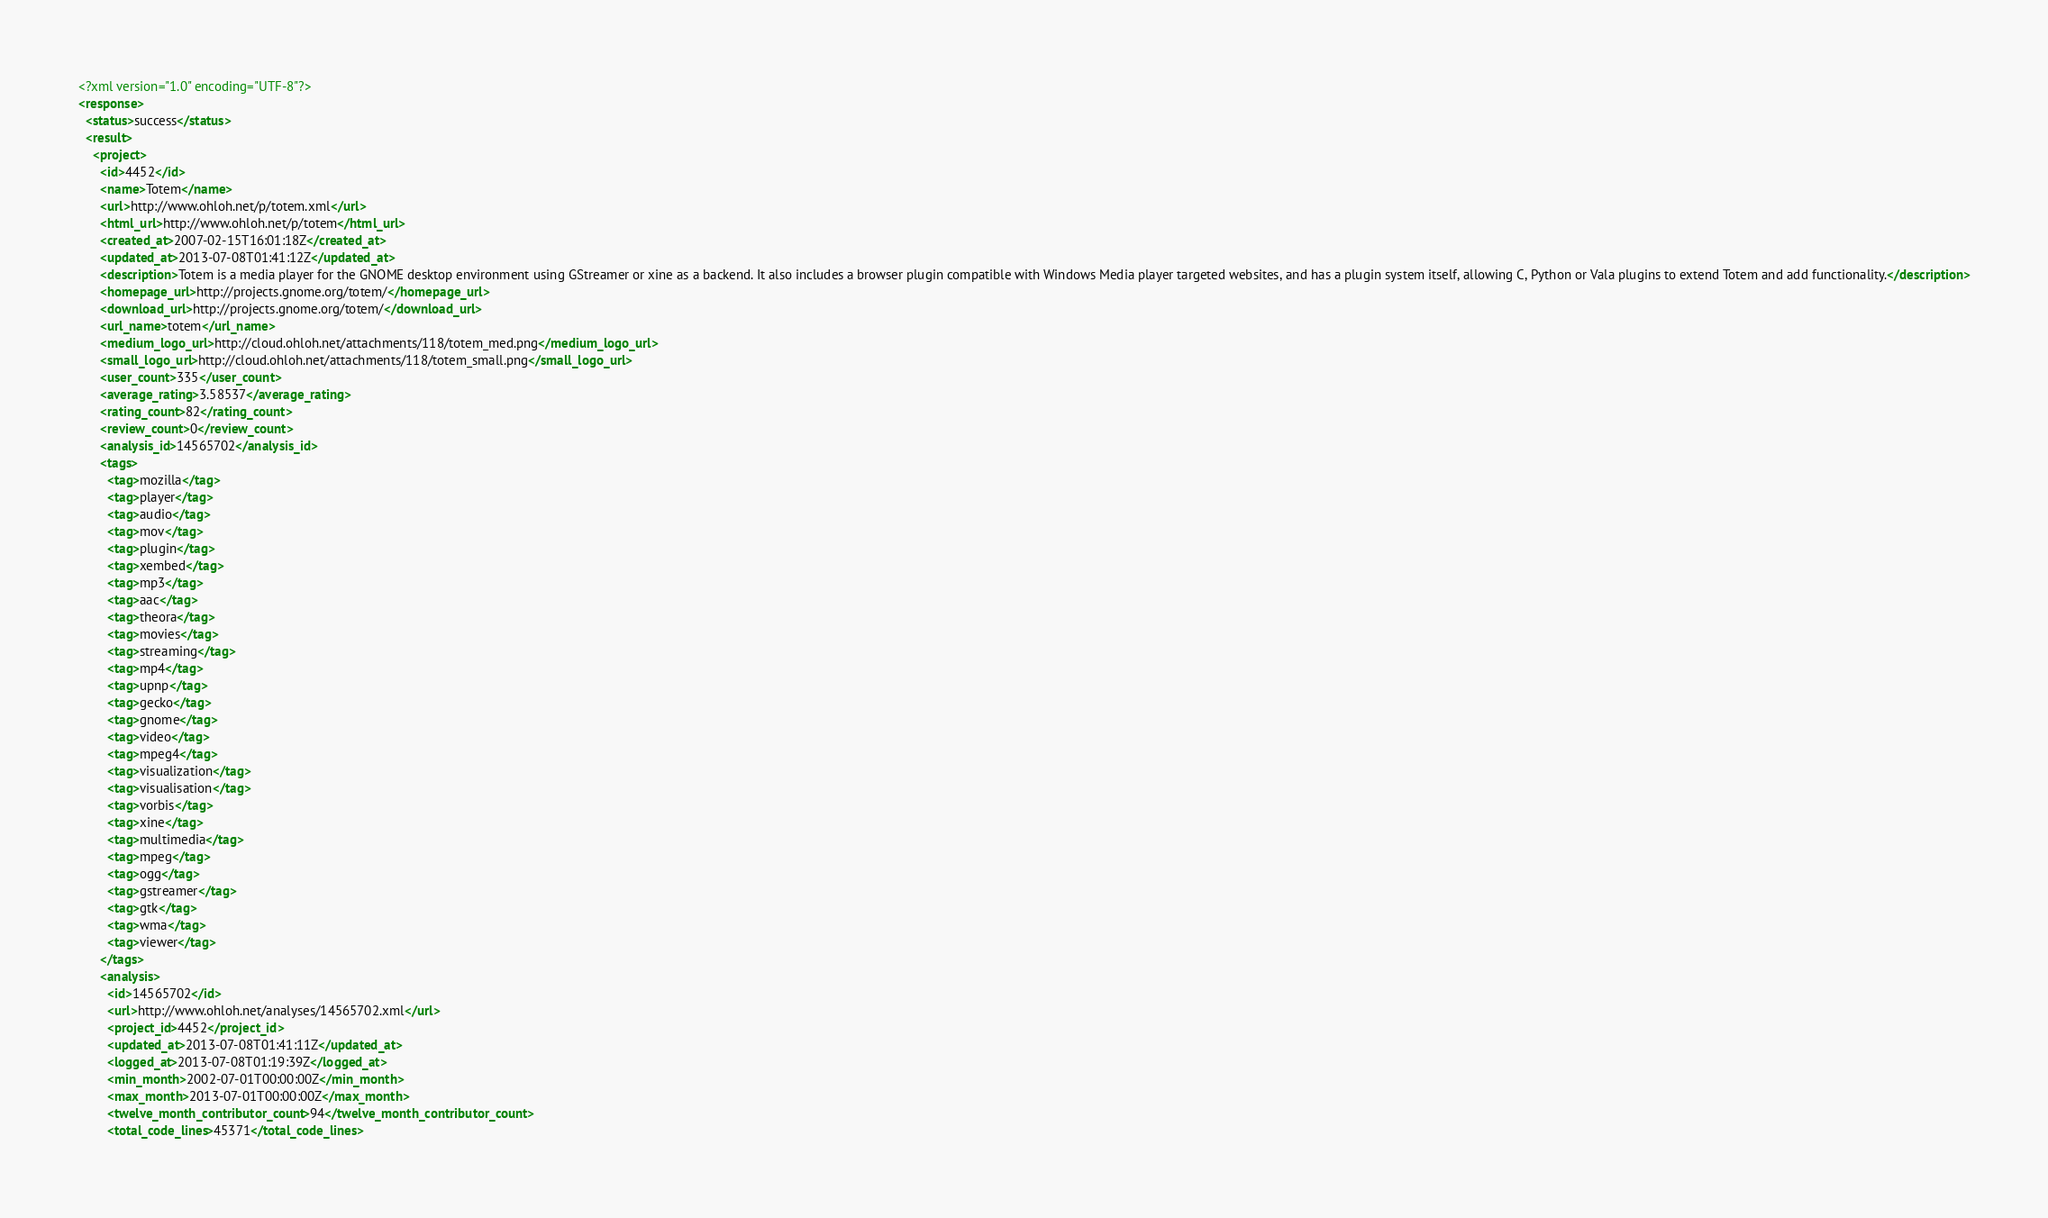Convert code to text. <code><loc_0><loc_0><loc_500><loc_500><_XML_><?xml version="1.0" encoding="UTF-8"?>
<response>
  <status>success</status>
  <result>
    <project>
      <id>4452</id>
      <name>Totem</name>
      <url>http://www.ohloh.net/p/totem.xml</url>
      <html_url>http://www.ohloh.net/p/totem</html_url>
      <created_at>2007-02-15T16:01:18Z</created_at>
      <updated_at>2013-07-08T01:41:12Z</updated_at>
      <description>Totem is a media player for the GNOME desktop environment using GStreamer or xine as a backend. It also includes a browser plugin compatible with Windows Media player targeted websites, and has a plugin system itself, allowing C, Python or Vala plugins to extend Totem and add functionality.</description>
      <homepage_url>http://projects.gnome.org/totem/</homepage_url>
      <download_url>http://projects.gnome.org/totem/</download_url>
      <url_name>totem</url_name>
      <medium_logo_url>http://cloud.ohloh.net/attachments/118/totem_med.png</medium_logo_url>
      <small_logo_url>http://cloud.ohloh.net/attachments/118/totem_small.png</small_logo_url>
      <user_count>335</user_count>
      <average_rating>3.58537</average_rating>
      <rating_count>82</rating_count>
      <review_count>0</review_count>
      <analysis_id>14565702</analysis_id>
      <tags>
        <tag>mozilla</tag>
        <tag>player</tag>
        <tag>audio</tag>
        <tag>mov</tag>
        <tag>plugin</tag>
        <tag>xembed</tag>
        <tag>mp3</tag>
        <tag>aac</tag>
        <tag>theora</tag>
        <tag>movies</tag>
        <tag>streaming</tag>
        <tag>mp4</tag>
        <tag>upnp</tag>
        <tag>gecko</tag>
        <tag>gnome</tag>
        <tag>video</tag>
        <tag>mpeg4</tag>
        <tag>visualization</tag>
        <tag>visualisation</tag>
        <tag>vorbis</tag>
        <tag>xine</tag>
        <tag>multimedia</tag>
        <tag>mpeg</tag>
        <tag>ogg</tag>
        <tag>gstreamer</tag>
        <tag>gtk</tag>
        <tag>wma</tag>
        <tag>viewer</tag>
      </tags>
      <analysis>
        <id>14565702</id>
        <url>http://www.ohloh.net/analyses/14565702.xml</url>
        <project_id>4452</project_id>
        <updated_at>2013-07-08T01:41:11Z</updated_at>
        <logged_at>2013-07-08T01:19:39Z</logged_at>
        <min_month>2002-07-01T00:00:00Z</min_month>
        <max_month>2013-07-01T00:00:00Z</max_month>
        <twelve_month_contributor_count>94</twelve_month_contributor_count>
        <total_code_lines>45371</total_code_lines></code> 